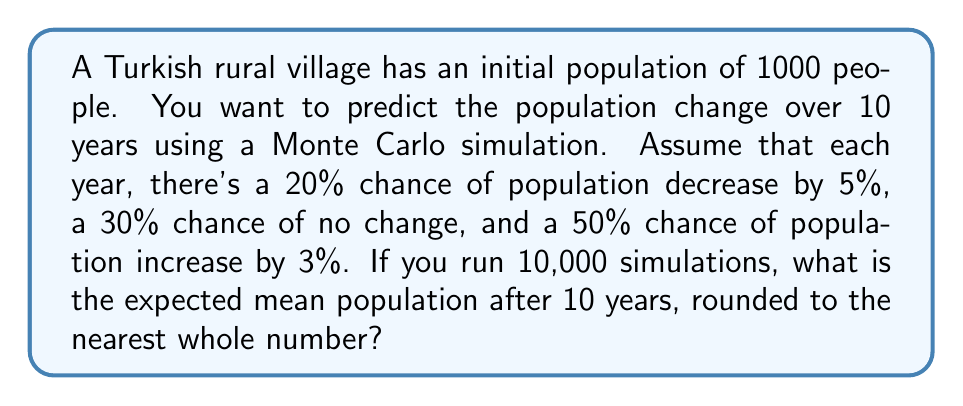Help me with this question. Let's approach this step-by-step:

1) First, we need to set up the probabilities and corresponding population changes:
   - 20% chance of 5% decrease: $0.20 \times 0.95 = 0.19$
   - 30% chance of no change: $0.30 \times 1.00 = 0.30$
   - 50% chance of 3% increase: $0.50 \times 1.03 = 0.515$

2) The expected value for a single year's change is:
   $E = 0.19 + 0.30 + 0.515 = 1.005$

3) Over 10 years, the expected population change is:
   $E^{10} = 1.005^{10} \approx 1.0511$

4) Therefore, the expected population after 10 years is:
   $1000 \times 1.0511 \approx 1051.1$

5) In a Monte Carlo simulation with 10,000 runs, we would expect the average result to converge to this expected value.

6) Rounding to the nearest whole number gives us 1051.
Answer: 1051 